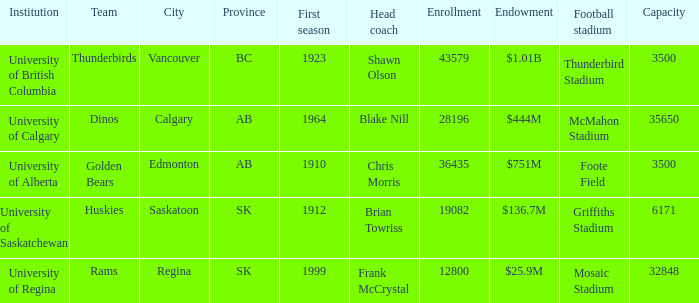What is the registration for foote field? 36435.0. 